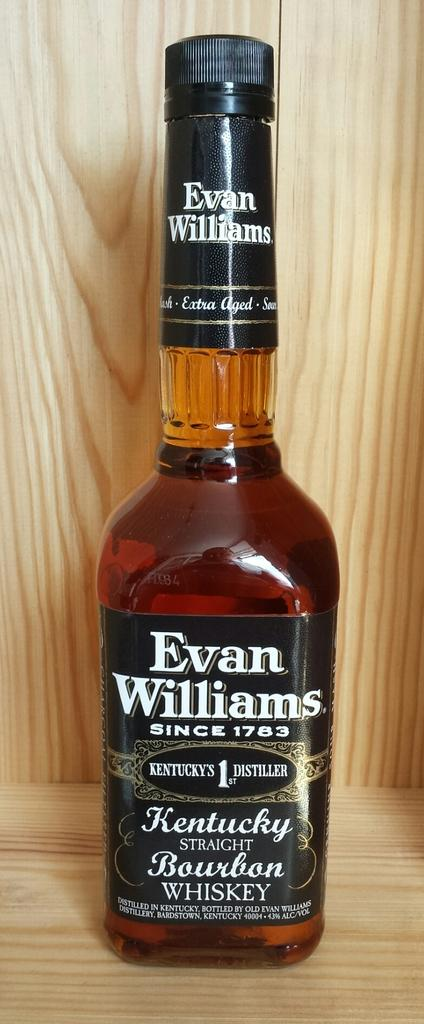<image>
Relay a brief, clear account of the picture shown. a full bottle of evan williams kentucky straight bourbon whiskey 